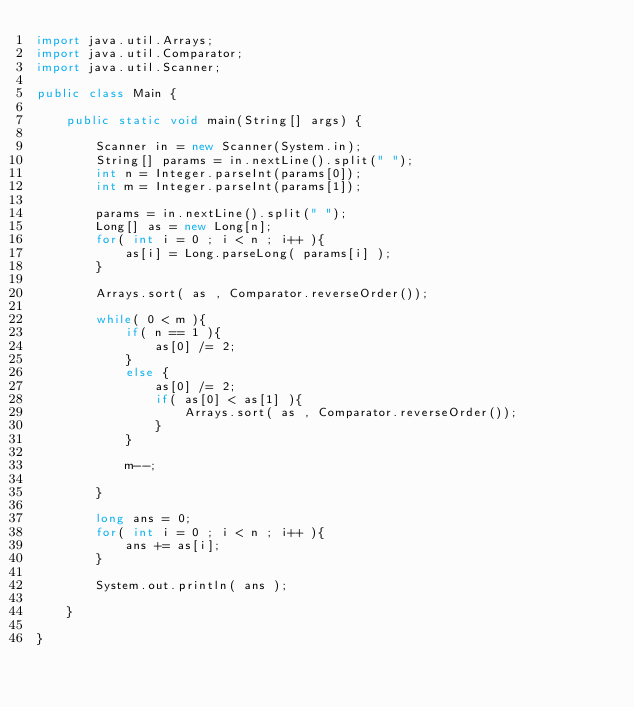<code> <loc_0><loc_0><loc_500><loc_500><_Java_>import java.util.Arrays;
import java.util.Comparator;
import java.util.Scanner;

public class Main {

    public static void main(String[] args) {

        Scanner in = new Scanner(System.in);
        String[] params = in.nextLine().split(" ");
        int n = Integer.parseInt(params[0]);
        int m = Integer.parseInt(params[1]);

        params = in.nextLine().split(" ");
        Long[] as = new Long[n];
        for( int i = 0 ; i < n ; i++ ){
            as[i] = Long.parseLong( params[i] );
        }

        Arrays.sort( as , Comparator.reverseOrder());

        while( 0 < m ){
            if( n == 1 ){
                as[0] /= 2;
            }
            else {
                as[0] /= 2;
                if( as[0] < as[1] ){
                    Arrays.sort( as , Comparator.reverseOrder());
                }
            }

            m--;

        }

        long ans = 0;
        for( int i = 0 ; i < n ; i++ ){
            ans += as[i];
        }

        System.out.println( ans );

    }

}
</code> 